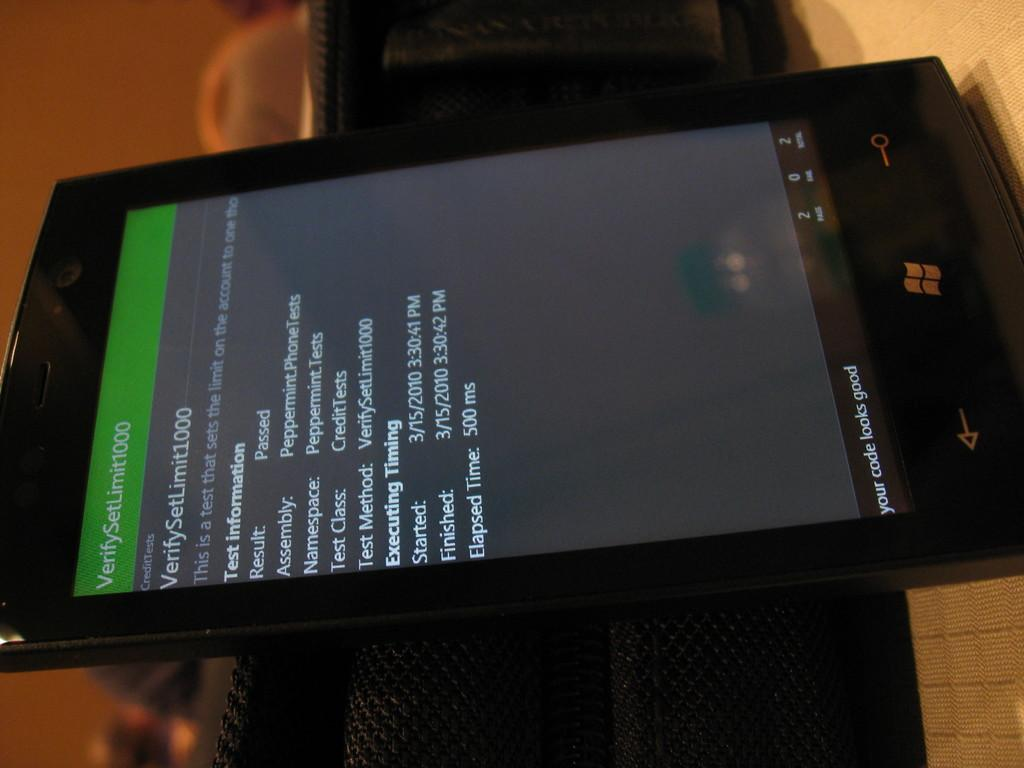<image>
Describe the image concisely. A smartphone has a VerifySetLimit message on its screen. 